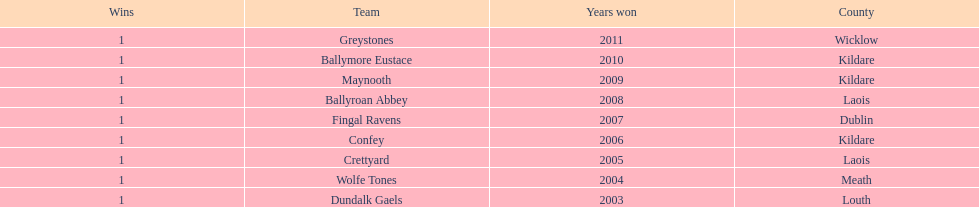How many wins does greystones have? 1. 